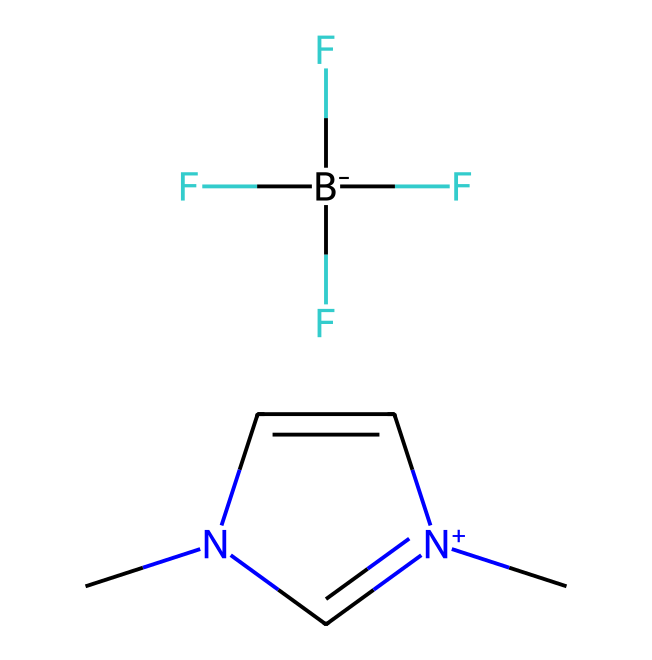What type of ionic liquid is represented in the SMILES? The SMILES representation indicates that this ionic liquid is an imidazolium-based ionic liquid due to the presence of the imidazolium ring with a nitrogen atom and a positively charged species denoted by "[n+]".
Answer: imidazolium-based How many nitrogen atoms are present in the structure? By examining the SMILES string, there are two nitrogen atoms represented in the imidazolium ring and one charge indication, making a total of two nitrogen atoms.
Answer: two What is the charge of the imidazolium cation? The presence of "[n+]" in the SMILES indicates that the imidazolium cation carries a positive charge.
Answer: positive Which component of the ionic liquid is responsible for its anionic property? The anionic property is provided by the presence of the "F[B-](F)(F)F" component in the SMILES, which represents the tetrafluoroborate anion.
Answer: tetrafluoroborate What functional groups are present in this ionic liquid? Analyzing the SMILES, there are a few functional groups such as the aromatic ring in imidazolium and fluoride groups in the tetrafluoroborate ion.
Answer: aromatic ring and fluoride groups Why is the presence of fluorine significant for this ionic liquid? The presence of highly electronegative fluorine atoms enhances the stability and solubility of this ionic liquid while potentially influencing its interactions with organic compounds and solvents, making it more favorable for applications such as stress relief in aromatherapy.
Answer: stability and solubility 